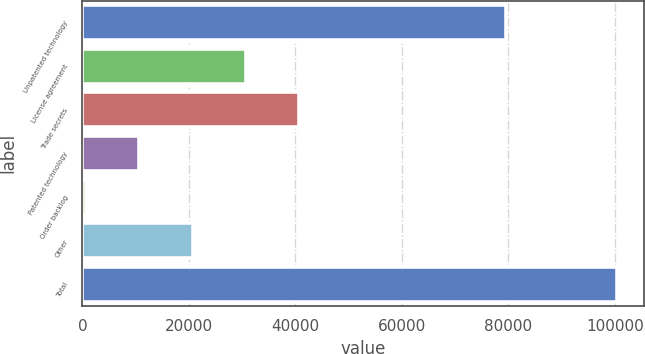<chart> <loc_0><loc_0><loc_500><loc_500><bar_chart><fcel>Unpatented technology<fcel>License agreement<fcel>Trade secrets<fcel>Patented technology<fcel>Order backlog<fcel>Other<fcel>Total<nl><fcel>79500<fcel>30642.6<fcel>40616.8<fcel>10694.2<fcel>720<fcel>20668.4<fcel>100462<nl></chart> 